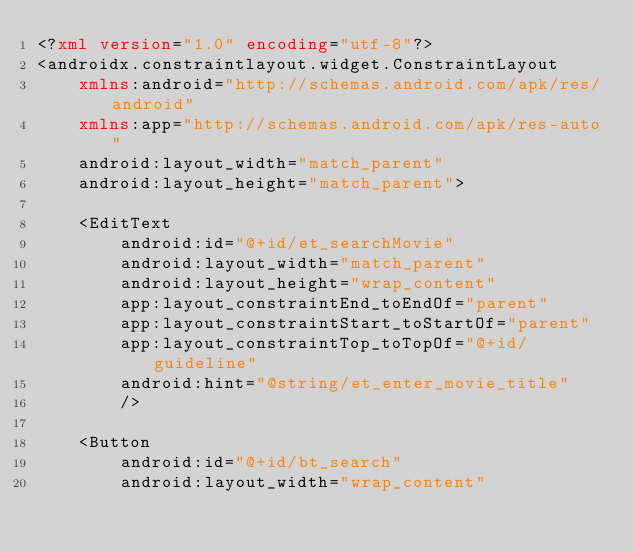Convert code to text. <code><loc_0><loc_0><loc_500><loc_500><_XML_><?xml version="1.0" encoding="utf-8"?>
<androidx.constraintlayout.widget.ConstraintLayout
    xmlns:android="http://schemas.android.com/apk/res/android"
    xmlns:app="http://schemas.android.com/apk/res-auto"
    android:layout_width="match_parent"
    android:layout_height="match_parent">

    <EditText
        android:id="@+id/et_searchMovie"
        android:layout_width="match_parent"
        android:layout_height="wrap_content"
        app:layout_constraintEnd_toEndOf="parent"
        app:layout_constraintStart_toStartOf="parent"
        app:layout_constraintTop_toTopOf="@+id/guideline"
        android:hint="@string/et_enter_movie_title"
        />

    <Button
        android:id="@+id/bt_search"
        android:layout_width="wrap_content"</code> 